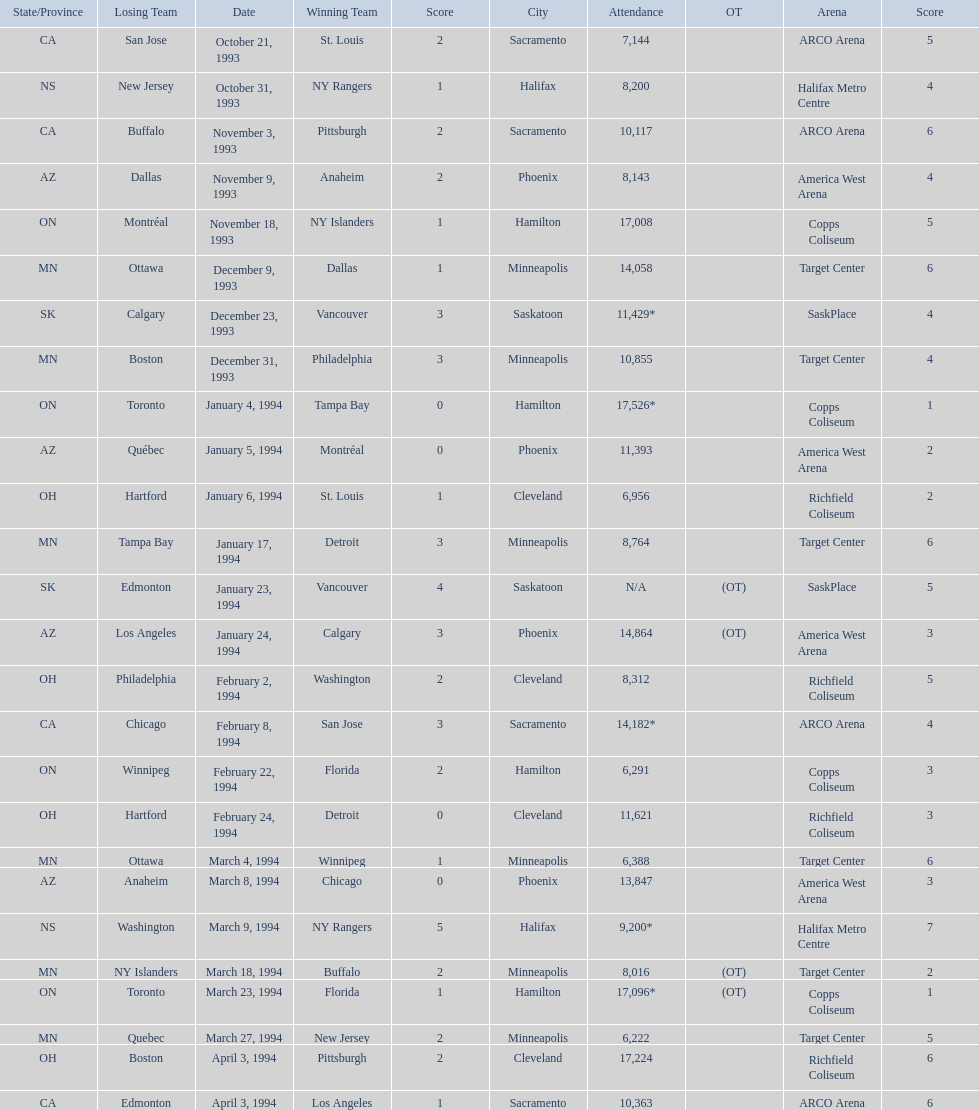Which was the highest attendance for a game? 17,526*. What was the date of the game with an attendance of 17,526? January 4, 1994. 